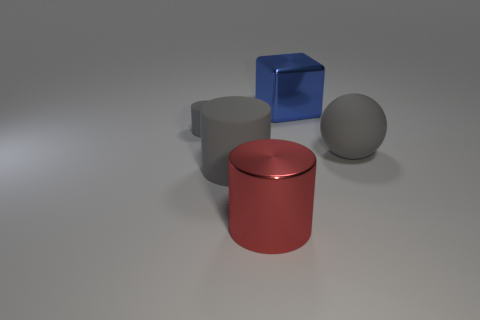Does the big sphere have the same color as the big rubber cylinder? yes 